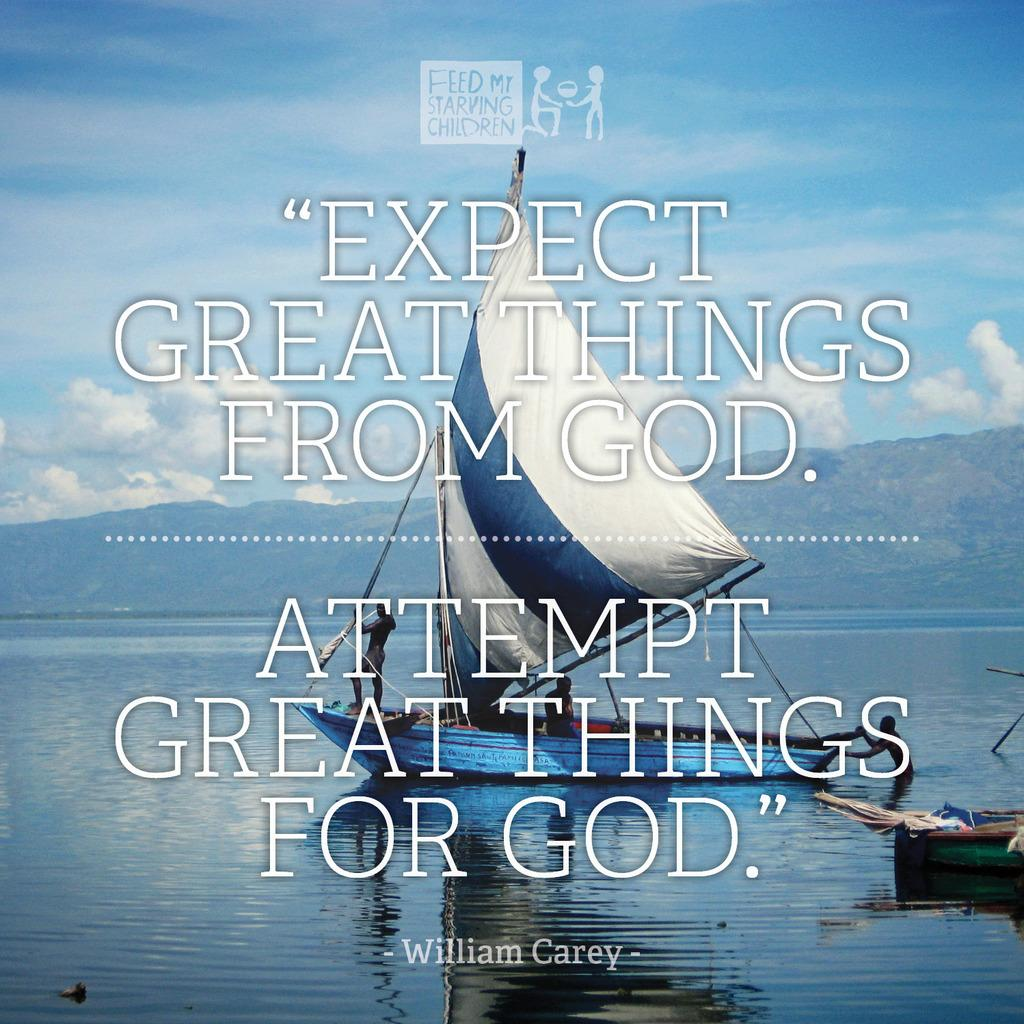<image>
Present a compact description of the photo's key features. A pictue of a sailboat with a quote from William Carey. 